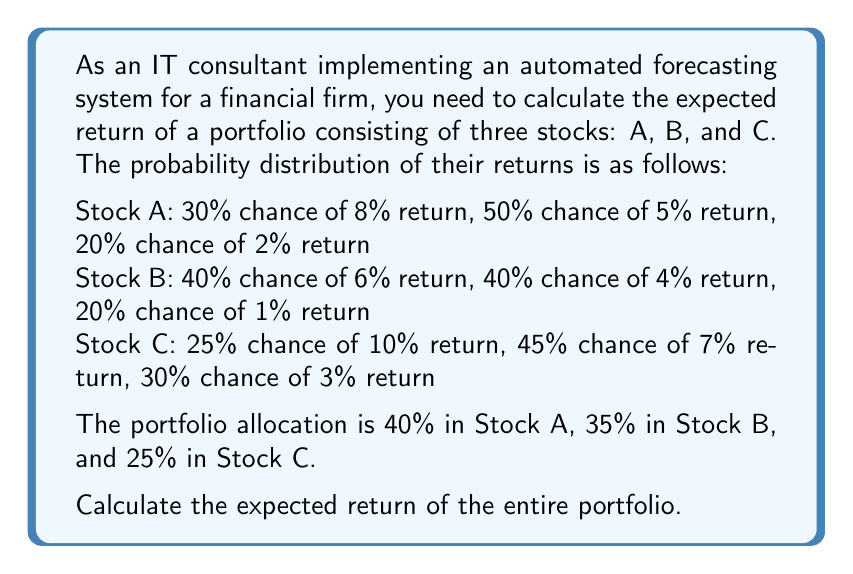Can you solve this math problem? To solve this problem, we'll follow these steps:

1. Calculate the expected return for each stock:

For Stock A:
$E(R_A) = 0.30 \times 8\% + 0.50 \times 5\% + 0.20 \times 2\% = 2.4\% + 2.5\% + 0.4\% = 5.3\%$

For Stock B:
$E(R_B) = 0.40 \times 6\% + 0.40 \times 4\% + 0.20 \times 1\% = 2.4\% + 1.6\% + 0.2\% = 4.2\%$

For Stock C:
$E(R_C) = 0.25 \times 10\% + 0.45 \times 7\% + 0.30 \times 3\% = 2.5\% + 3.15\% + 0.9\% = 6.55\%$

2. Calculate the weighted average of the expected returns based on the portfolio allocation:

Let $E(R_P)$ be the expected return of the portfolio.

$E(R_P) = 0.40 \times E(R_A) + 0.35 \times E(R_B) + 0.25 \times E(R_C)$

3. Substitute the values:

$E(R_P) = 0.40 \times 5.3\% + 0.35 \times 4.2\% + 0.25 \times 6.55\%$

4. Perform the calculations:

$E(R_P) = 2.12\% + 1.47\% + 1.6375\% = 5.2275\%$

Therefore, the expected return of the entire portfolio is 5.2275%.
Answer: 5.2275% 